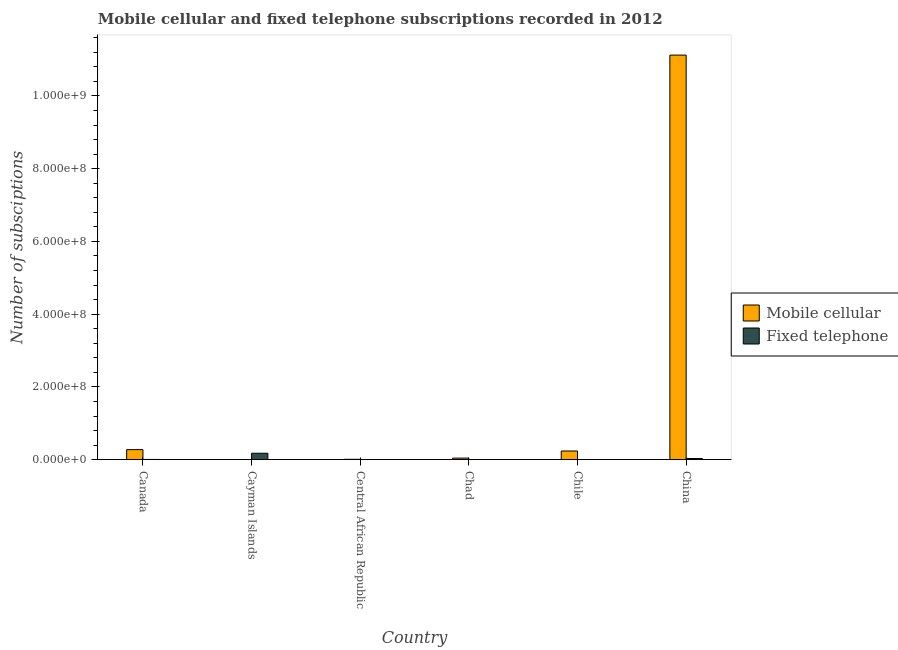How many bars are there on the 1st tick from the left?
Make the answer very short. 2. In how many cases, is the number of bars for a given country not equal to the number of legend labels?
Make the answer very short. 0. What is the number of mobile cellular subscriptions in China?
Provide a succinct answer. 1.11e+09. Across all countries, what is the maximum number of mobile cellular subscriptions?
Provide a short and direct response. 1.11e+09. Across all countries, what is the minimum number of mobile cellular subscriptions?
Keep it short and to the point. 9.88e+04. In which country was the number of fixed telephone subscriptions maximum?
Your answer should be compact. Cayman Islands. In which country was the number of mobile cellular subscriptions minimum?
Make the answer very short. Cayman Islands. What is the total number of mobile cellular subscriptions in the graph?
Your answer should be compact. 1.17e+09. What is the difference between the number of mobile cellular subscriptions in Canada and that in Central African Republic?
Your response must be concise. 2.66e+07. What is the difference between the number of mobile cellular subscriptions in Cayman Islands and the number of fixed telephone subscriptions in Chile?
Give a very brief answer. 7.09e+04. What is the average number of fixed telephone subscriptions per country?
Keep it short and to the point. 3.64e+06. What is the difference between the number of mobile cellular subscriptions and number of fixed telephone subscriptions in Canada?
Ensure brevity in your answer.  2.70e+07. In how many countries, is the number of mobile cellular subscriptions greater than 880000000 ?
Your response must be concise. 1. What is the ratio of the number of mobile cellular subscriptions in Chile to that in China?
Ensure brevity in your answer.  0.02. What is the difference between the highest and the second highest number of fixed telephone subscriptions?
Ensure brevity in your answer.  1.44e+07. What is the difference between the highest and the lowest number of mobile cellular subscriptions?
Your answer should be compact. 1.11e+09. Is the sum of the number of mobile cellular subscriptions in Chad and Chile greater than the maximum number of fixed telephone subscriptions across all countries?
Provide a succinct answer. Yes. What does the 1st bar from the left in Canada represents?
Offer a terse response. Mobile cellular. What does the 1st bar from the right in Chile represents?
Make the answer very short. Fixed telephone. How many bars are there?
Make the answer very short. 12. Are all the bars in the graph horizontal?
Your answer should be compact. No. How many countries are there in the graph?
Provide a succinct answer. 6. Does the graph contain any zero values?
Provide a short and direct response. No. How many legend labels are there?
Your response must be concise. 2. What is the title of the graph?
Give a very brief answer. Mobile cellular and fixed telephone subscriptions recorded in 2012. What is the label or title of the X-axis?
Ensure brevity in your answer.  Country. What is the label or title of the Y-axis?
Provide a short and direct response. Number of subsciptions. What is the Number of subsciptions of Mobile cellular in Canada?
Offer a very short reply. 2.77e+07. What is the Number of subsciptions of Fixed telephone in Canada?
Offer a terse response. 7.37e+05. What is the Number of subsciptions in Mobile cellular in Cayman Islands?
Offer a terse response. 9.88e+04. What is the Number of subsciptions in Fixed telephone in Cayman Islands?
Your answer should be very brief. 1.77e+07. What is the Number of subsciptions in Mobile cellular in Central African Republic?
Your answer should be very brief. 1.14e+06. What is the Number of subsciptions of Fixed telephone in Central African Republic?
Your answer should be compact. 3.74e+04. What is the Number of subsciptions in Mobile cellular in Chad?
Your answer should be very brief. 4.40e+06. What is the Number of subsciptions in Fixed telephone in Chad?
Offer a very short reply. 823. What is the Number of subsciptions in Mobile cellular in Chile?
Your answer should be compact. 2.39e+07. What is the Number of subsciptions in Fixed telephone in Chile?
Make the answer very short. 2.79e+04. What is the Number of subsciptions in Mobile cellular in China?
Provide a short and direct response. 1.11e+09. What is the Number of subsciptions of Fixed telephone in China?
Make the answer very short. 3.28e+06. Across all countries, what is the maximum Number of subsciptions of Mobile cellular?
Your answer should be compact. 1.11e+09. Across all countries, what is the maximum Number of subsciptions in Fixed telephone?
Offer a terse response. 1.77e+07. Across all countries, what is the minimum Number of subsciptions of Mobile cellular?
Your answer should be very brief. 9.88e+04. Across all countries, what is the minimum Number of subsciptions in Fixed telephone?
Your answer should be very brief. 823. What is the total Number of subsciptions in Mobile cellular in the graph?
Your answer should be very brief. 1.17e+09. What is the total Number of subsciptions in Fixed telephone in the graph?
Provide a short and direct response. 2.18e+07. What is the difference between the Number of subsciptions in Mobile cellular in Canada and that in Cayman Islands?
Your response must be concise. 2.76e+07. What is the difference between the Number of subsciptions of Fixed telephone in Canada and that in Cayman Islands?
Keep it short and to the point. -1.70e+07. What is the difference between the Number of subsciptions in Mobile cellular in Canada and that in Central African Republic?
Your answer should be very brief. 2.66e+07. What is the difference between the Number of subsciptions in Fixed telephone in Canada and that in Central African Republic?
Make the answer very short. 7.00e+05. What is the difference between the Number of subsciptions in Mobile cellular in Canada and that in Chad?
Provide a short and direct response. 2.33e+07. What is the difference between the Number of subsciptions of Fixed telephone in Canada and that in Chad?
Keep it short and to the point. 7.37e+05. What is the difference between the Number of subsciptions in Mobile cellular in Canada and that in Chile?
Ensure brevity in your answer.  3.78e+06. What is the difference between the Number of subsciptions of Fixed telephone in Canada and that in Chile?
Ensure brevity in your answer.  7.10e+05. What is the difference between the Number of subsciptions of Mobile cellular in Canada and that in China?
Ensure brevity in your answer.  -1.08e+09. What is the difference between the Number of subsciptions of Fixed telephone in Canada and that in China?
Offer a very short reply. -2.54e+06. What is the difference between the Number of subsciptions in Mobile cellular in Cayman Islands and that in Central African Republic?
Offer a very short reply. -1.04e+06. What is the difference between the Number of subsciptions in Fixed telephone in Cayman Islands and that in Central African Republic?
Keep it short and to the point. 1.77e+07. What is the difference between the Number of subsciptions in Mobile cellular in Cayman Islands and that in Chad?
Make the answer very short. -4.30e+06. What is the difference between the Number of subsciptions of Fixed telephone in Cayman Islands and that in Chad?
Your answer should be very brief. 1.77e+07. What is the difference between the Number of subsciptions in Mobile cellular in Cayman Islands and that in Chile?
Your answer should be compact. -2.38e+07. What is the difference between the Number of subsciptions of Fixed telephone in Cayman Islands and that in Chile?
Offer a terse response. 1.77e+07. What is the difference between the Number of subsciptions in Mobile cellular in Cayman Islands and that in China?
Your response must be concise. -1.11e+09. What is the difference between the Number of subsciptions in Fixed telephone in Cayman Islands and that in China?
Your response must be concise. 1.44e+07. What is the difference between the Number of subsciptions in Mobile cellular in Central African Republic and that in Chad?
Offer a terse response. -3.26e+06. What is the difference between the Number of subsciptions in Fixed telephone in Central African Republic and that in Chad?
Provide a succinct answer. 3.66e+04. What is the difference between the Number of subsciptions in Mobile cellular in Central African Republic and that in Chile?
Give a very brief answer. -2.28e+07. What is the difference between the Number of subsciptions in Fixed telephone in Central African Republic and that in Chile?
Provide a short and direct response. 9455. What is the difference between the Number of subsciptions in Mobile cellular in Central African Republic and that in China?
Keep it short and to the point. -1.11e+09. What is the difference between the Number of subsciptions in Fixed telephone in Central African Republic and that in China?
Offer a very short reply. -3.24e+06. What is the difference between the Number of subsciptions of Mobile cellular in Chad and that in Chile?
Make the answer very short. -1.95e+07. What is the difference between the Number of subsciptions of Fixed telephone in Chad and that in Chile?
Give a very brief answer. -2.71e+04. What is the difference between the Number of subsciptions of Mobile cellular in Chad and that in China?
Make the answer very short. -1.11e+09. What is the difference between the Number of subsciptions in Fixed telephone in Chad and that in China?
Your answer should be compact. -3.28e+06. What is the difference between the Number of subsciptions in Mobile cellular in Chile and that in China?
Provide a succinct answer. -1.09e+09. What is the difference between the Number of subsciptions in Fixed telephone in Chile and that in China?
Keep it short and to the point. -3.25e+06. What is the difference between the Number of subsciptions in Mobile cellular in Canada and the Number of subsciptions in Fixed telephone in Cayman Islands?
Provide a short and direct response. 9.99e+06. What is the difference between the Number of subsciptions in Mobile cellular in Canada and the Number of subsciptions in Fixed telephone in Central African Republic?
Keep it short and to the point. 2.77e+07. What is the difference between the Number of subsciptions in Mobile cellular in Canada and the Number of subsciptions in Fixed telephone in Chad?
Give a very brief answer. 2.77e+07. What is the difference between the Number of subsciptions of Mobile cellular in Canada and the Number of subsciptions of Fixed telephone in Chile?
Your response must be concise. 2.77e+07. What is the difference between the Number of subsciptions of Mobile cellular in Canada and the Number of subsciptions of Fixed telephone in China?
Ensure brevity in your answer.  2.44e+07. What is the difference between the Number of subsciptions of Mobile cellular in Cayman Islands and the Number of subsciptions of Fixed telephone in Central African Republic?
Your answer should be very brief. 6.14e+04. What is the difference between the Number of subsciptions in Mobile cellular in Cayman Islands and the Number of subsciptions in Fixed telephone in Chad?
Provide a succinct answer. 9.80e+04. What is the difference between the Number of subsciptions of Mobile cellular in Cayman Islands and the Number of subsciptions of Fixed telephone in Chile?
Provide a short and direct response. 7.09e+04. What is the difference between the Number of subsciptions of Mobile cellular in Cayman Islands and the Number of subsciptions of Fixed telephone in China?
Provide a succinct answer. -3.18e+06. What is the difference between the Number of subsciptions in Mobile cellular in Central African Republic and the Number of subsciptions in Fixed telephone in Chad?
Make the answer very short. 1.14e+06. What is the difference between the Number of subsciptions in Mobile cellular in Central African Republic and the Number of subsciptions in Fixed telephone in Chile?
Give a very brief answer. 1.12e+06. What is the difference between the Number of subsciptions in Mobile cellular in Central African Republic and the Number of subsciptions in Fixed telephone in China?
Your response must be concise. -2.14e+06. What is the difference between the Number of subsciptions of Mobile cellular in Chad and the Number of subsciptions of Fixed telephone in Chile?
Offer a terse response. 4.37e+06. What is the difference between the Number of subsciptions of Mobile cellular in Chad and the Number of subsciptions of Fixed telephone in China?
Offer a very short reply. 1.12e+06. What is the difference between the Number of subsciptions in Mobile cellular in Chile and the Number of subsciptions in Fixed telephone in China?
Ensure brevity in your answer.  2.07e+07. What is the average Number of subsciptions in Mobile cellular per country?
Give a very brief answer. 1.95e+08. What is the average Number of subsciptions in Fixed telephone per country?
Your answer should be very brief. 3.64e+06. What is the difference between the Number of subsciptions in Mobile cellular and Number of subsciptions in Fixed telephone in Canada?
Your answer should be compact. 2.70e+07. What is the difference between the Number of subsciptions of Mobile cellular and Number of subsciptions of Fixed telephone in Cayman Islands?
Provide a short and direct response. -1.76e+07. What is the difference between the Number of subsciptions in Mobile cellular and Number of subsciptions in Fixed telephone in Central African Republic?
Provide a succinct answer. 1.11e+06. What is the difference between the Number of subsciptions in Mobile cellular and Number of subsciptions in Fixed telephone in Chad?
Keep it short and to the point. 4.40e+06. What is the difference between the Number of subsciptions of Mobile cellular and Number of subsciptions of Fixed telephone in Chile?
Keep it short and to the point. 2.39e+07. What is the difference between the Number of subsciptions of Mobile cellular and Number of subsciptions of Fixed telephone in China?
Ensure brevity in your answer.  1.11e+09. What is the ratio of the Number of subsciptions in Mobile cellular in Canada to that in Cayman Islands?
Offer a terse response. 280.47. What is the ratio of the Number of subsciptions in Fixed telephone in Canada to that in Cayman Islands?
Your answer should be very brief. 0.04. What is the ratio of the Number of subsciptions in Mobile cellular in Canada to that in Central African Republic?
Ensure brevity in your answer.  24.25. What is the ratio of the Number of subsciptions in Fixed telephone in Canada to that in Central African Republic?
Your response must be concise. 19.72. What is the ratio of the Number of subsciptions in Mobile cellular in Canada to that in Chad?
Keep it short and to the point. 6.3. What is the ratio of the Number of subsciptions in Fixed telephone in Canada to that in Chad?
Your response must be concise. 896.04. What is the ratio of the Number of subsciptions in Mobile cellular in Canada to that in Chile?
Give a very brief answer. 1.16. What is the ratio of the Number of subsciptions of Fixed telephone in Canada to that in Chile?
Provide a succinct answer. 26.4. What is the ratio of the Number of subsciptions in Mobile cellular in Canada to that in China?
Your response must be concise. 0.02. What is the ratio of the Number of subsciptions of Fixed telephone in Canada to that in China?
Provide a short and direct response. 0.22. What is the ratio of the Number of subsciptions in Mobile cellular in Cayman Islands to that in Central African Republic?
Your response must be concise. 0.09. What is the ratio of the Number of subsciptions in Fixed telephone in Cayman Islands to that in Central African Republic?
Your response must be concise. 474.06. What is the ratio of the Number of subsciptions of Mobile cellular in Cayman Islands to that in Chad?
Make the answer very short. 0.02. What is the ratio of the Number of subsciptions in Fixed telephone in Cayman Islands to that in Chad?
Ensure brevity in your answer.  2.15e+04. What is the ratio of the Number of subsciptions of Mobile cellular in Cayman Islands to that in Chile?
Provide a succinct answer. 0. What is the ratio of the Number of subsciptions of Fixed telephone in Cayman Islands to that in Chile?
Provide a succinct answer. 634.5. What is the ratio of the Number of subsciptions in Mobile cellular in Cayman Islands to that in China?
Your answer should be compact. 0. What is the ratio of the Number of subsciptions in Fixed telephone in Cayman Islands to that in China?
Make the answer very short. 5.4. What is the ratio of the Number of subsciptions of Mobile cellular in Central African Republic to that in Chad?
Your answer should be compact. 0.26. What is the ratio of the Number of subsciptions of Fixed telephone in Central African Republic to that in Chad?
Offer a very short reply. 45.43. What is the ratio of the Number of subsciptions of Mobile cellular in Central African Republic to that in Chile?
Provide a short and direct response. 0.05. What is the ratio of the Number of subsciptions in Fixed telephone in Central African Republic to that in Chile?
Keep it short and to the point. 1.34. What is the ratio of the Number of subsciptions of Fixed telephone in Central African Republic to that in China?
Offer a very short reply. 0.01. What is the ratio of the Number of subsciptions in Mobile cellular in Chad to that in Chile?
Keep it short and to the point. 0.18. What is the ratio of the Number of subsciptions in Fixed telephone in Chad to that in Chile?
Offer a terse response. 0.03. What is the ratio of the Number of subsciptions in Mobile cellular in Chad to that in China?
Your answer should be compact. 0. What is the ratio of the Number of subsciptions in Fixed telephone in Chad to that in China?
Your answer should be very brief. 0. What is the ratio of the Number of subsciptions of Mobile cellular in Chile to that in China?
Your answer should be very brief. 0.02. What is the ratio of the Number of subsciptions of Fixed telephone in Chile to that in China?
Provide a succinct answer. 0.01. What is the difference between the highest and the second highest Number of subsciptions in Mobile cellular?
Give a very brief answer. 1.08e+09. What is the difference between the highest and the second highest Number of subsciptions of Fixed telephone?
Provide a succinct answer. 1.44e+07. What is the difference between the highest and the lowest Number of subsciptions of Mobile cellular?
Your response must be concise. 1.11e+09. What is the difference between the highest and the lowest Number of subsciptions of Fixed telephone?
Your response must be concise. 1.77e+07. 